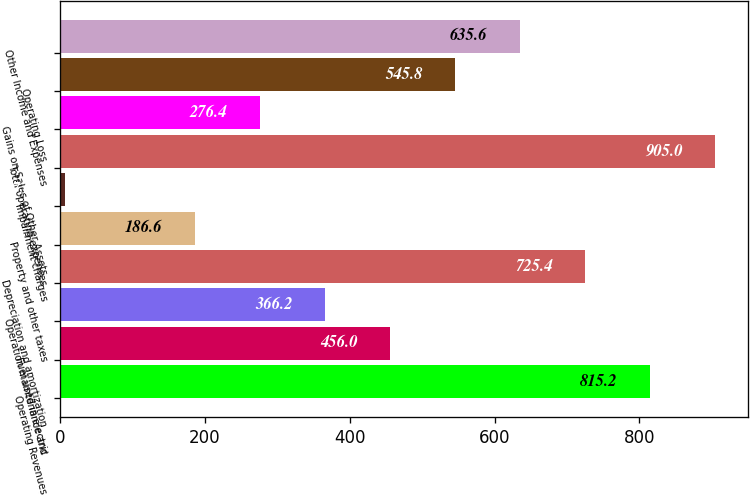<chart> <loc_0><loc_0><loc_500><loc_500><bar_chart><fcel>Operating Revenues<fcel>Fuel used in electric<fcel>Operation maintenance and<fcel>Depreciation and amortization<fcel>Property and other taxes<fcel>Impairment charges<fcel>Total operating expenses<fcel>Gains on Sales of Other Assets<fcel>Operating Loss<fcel>Other Income and Expenses<nl><fcel>815.2<fcel>456<fcel>366.2<fcel>725.4<fcel>186.6<fcel>7<fcel>905<fcel>276.4<fcel>545.8<fcel>635.6<nl></chart> 